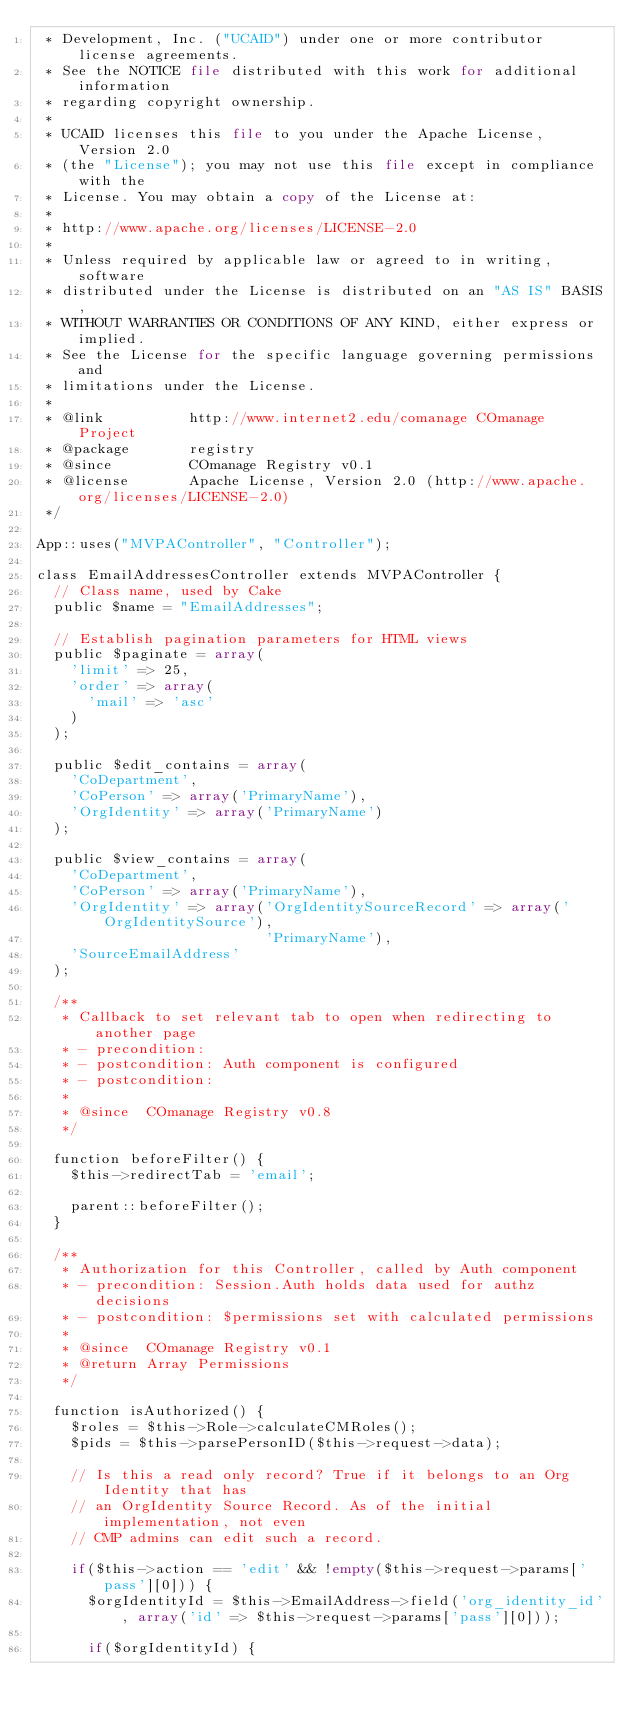<code> <loc_0><loc_0><loc_500><loc_500><_PHP_> * Development, Inc. ("UCAID") under one or more contributor license agreements.
 * See the NOTICE file distributed with this work for additional information
 * regarding copyright ownership.
 *
 * UCAID licenses this file to you under the Apache License, Version 2.0
 * (the "License"); you may not use this file except in compliance with the
 * License. You may obtain a copy of the License at:
 *
 * http://www.apache.org/licenses/LICENSE-2.0
 *
 * Unless required by applicable law or agreed to in writing, software
 * distributed under the License is distributed on an "AS IS" BASIS,
 * WITHOUT WARRANTIES OR CONDITIONS OF ANY KIND, either express or implied.
 * See the License for the specific language governing permissions and
 * limitations under the License.
 * 
 * @link          http://www.internet2.edu/comanage COmanage Project
 * @package       registry
 * @since         COmanage Registry v0.1
 * @license       Apache License, Version 2.0 (http://www.apache.org/licenses/LICENSE-2.0)
 */

App::uses("MVPAController", "Controller");

class EmailAddressesController extends MVPAController {
  // Class name, used by Cake
  public $name = "EmailAddresses";
  
  // Establish pagination parameters for HTML views
  public $paginate = array(
    'limit' => 25,
    'order' => array(
      'mail' => 'asc'
    )
  );
  
  public $edit_contains = array(
    'CoDepartment',
    'CoPerson' => array('PrimaryName'),
    'OrgIdentity' => array('PrimaryName')
  );

  public $view_contains = array(
    'CoDepartment',
    'CoPerson' => array('PrimaryName'),
    'OrgIdentity' => array('OrgIdentitySourceRecord' => array('OrgIdentitySource'),
                           'PrimaryName'),
    'SourceEmailAddress'
  );
  
  /**
   * Callback to set relevant tab to open when redirecting to another page
   * - precondition:
   * - postcondition: Auth component is configured
   * - postcondition:
   *
   * @since  COmanage Registry v0.8
   */

  function beforeFilter() {
    $this->redirectTab = 'email';

    parent::beforeFilter();
  }

  /**
   * Authorization for this Controller, called by Auth component
   * - precondition: Session.Auth holds data used for authz decisions
   * - postcondition: $permissions set with calculated permissions
   *
   * @since  COmanage Registry v0.1
   * @return Array Permissions
   */
  
  function isAuthorized() {
    $roles = $this->Role->calculateCMRoles();
    $pids = $this->parsePersonID($this->request->data);
    
    // Is this a read only record? True if it belongs to an Org Identity that has
    // an OrgIdentity Source Record. As of the initial implementation, not even
    // CMP admins can edit such a record.
    
    if($this->action == 'edit' && !empty($this->request->params['pass'][0])) {
      $orgIdentityId = $this->EmailAddress->field('org_identity_id', array('id' => $this->request->params['pass'][0]));
      
      if($orgIdentityId) {</code> 